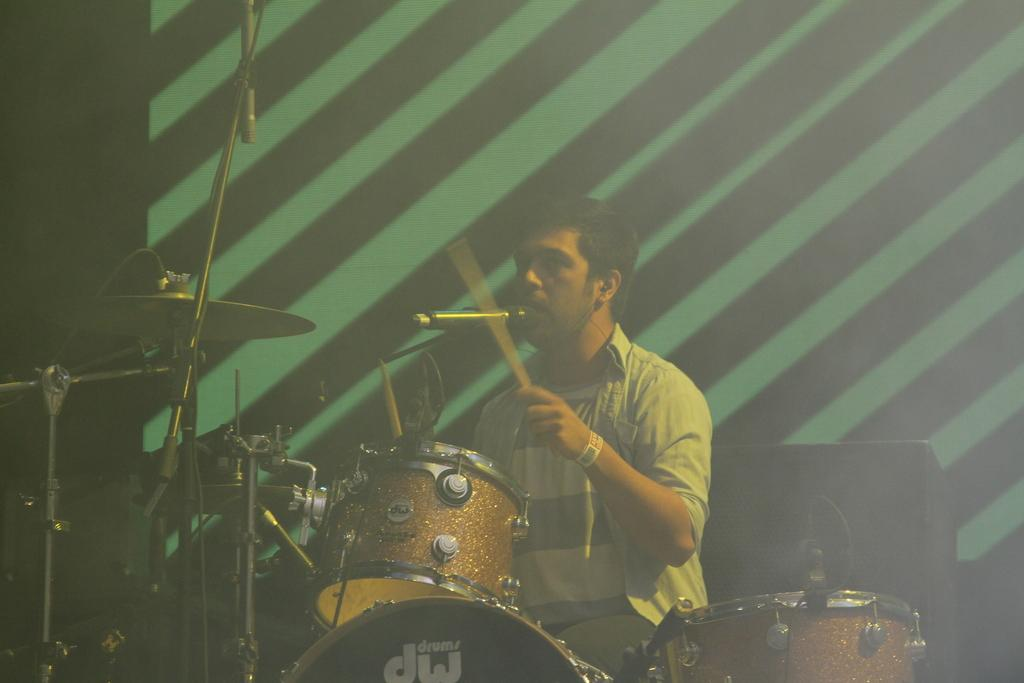What is the person in the image doing? The person in the image is playing jazz and singing. What equipment is visible in the image? There are microphones in the image. What can be seen in the background of the image? There is a speaker in the background of the image, and the background is black and green in color. What type of yam is being served on the table in the image? There is no table or yam present in the image; it features a person playing jazz and singing. Can you see any ghosts in the image? There are no ghosts present in the image. 